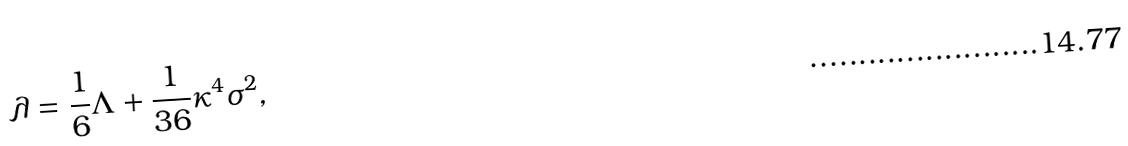<formula> <loc_0><loc_0><loc_500><loc_500>\lambda = \frac { 1 } { 6 } \Lambda + \frac { 1 } { 3 6 } \kappa ^ { 4 } \sigma ^ { 2 } ,</formula> 